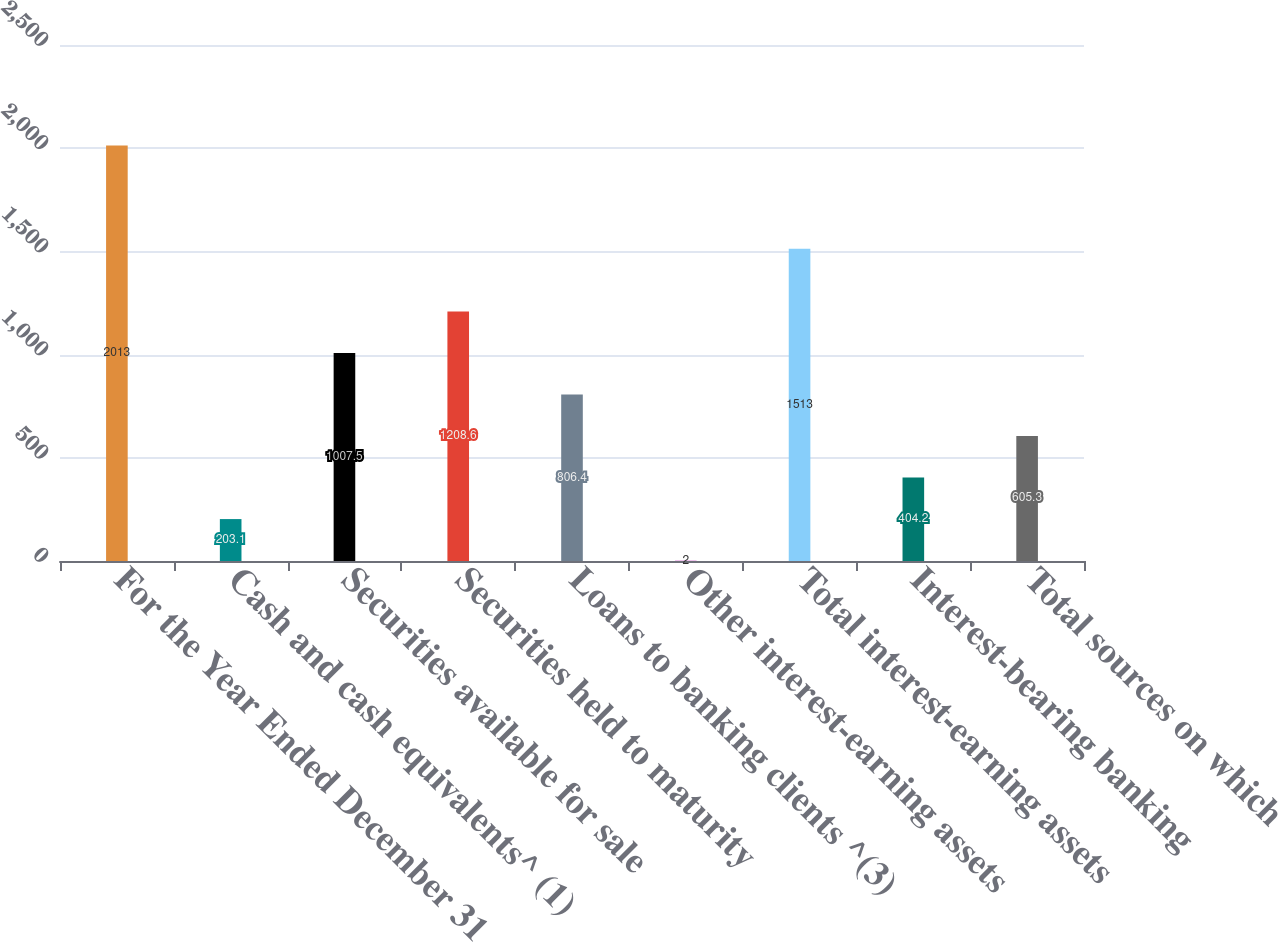Convert chart to OTSL. <chart><loc_0><loc_0><loc_500><loc_500><bar_chart><fcel>For the Year Ended December 31<fcel>Cash and cash equivalents^ (1)<fcel>Securities available for sale<fcel>Securities held to maturity<fcel>Loans to banking clients ^(3)<fcel>Other interest-earning assets<fcel>Total interest-earning assets<fcel>Interest-bearing banking<fcel>Total sources on which<nl><fcel>2013<fcel>203.1<fcel>1007.5<fcel>1208.6<fcel>806.4<fcel>2<fcel>1513<fcel>404.2<fcel>605.3<nl></chart> 